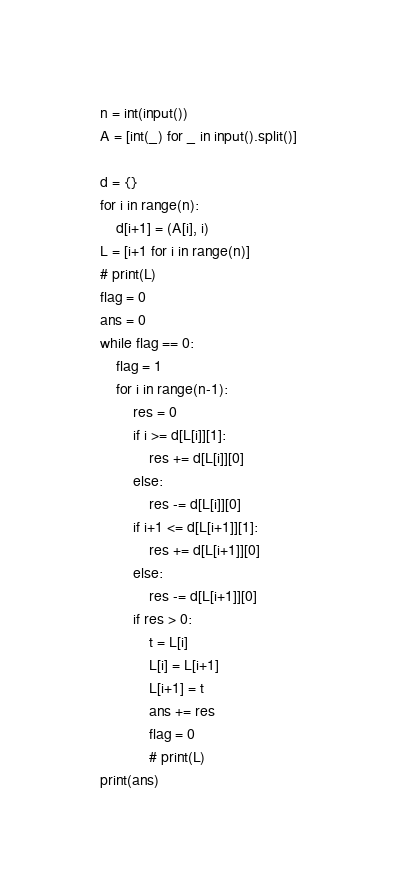<code> <loc_0><loc_0><loc_500><loc_500><_Python_>n = int(input())
A = [int(_) for _ in input().split()]

d = {}
for i in range(n):
    d[i+1] = (A[i], i)
L = [i+1 for i in range(n)]
# print(L)
flag = 0
ans = 0
while flag == 0:
    flag = 1
    for i in range(n-1):
        res = 0
        if i >= d[L[i]][1]:
            res += d[L[i]][0]
        else:
            res -= d[L[i]][0]
        if i+1 <= d[L[i+1]][1]:
            res += d[L[i+1]][0]
        else:
            res -= d[L[i+1]][0]
        if res > 0:
            t = L[i]
            L[i] = L[i+1]
            L[i+1] = t
            ans += res
            flag = 0
            # print(L)
print(ans)</code> 